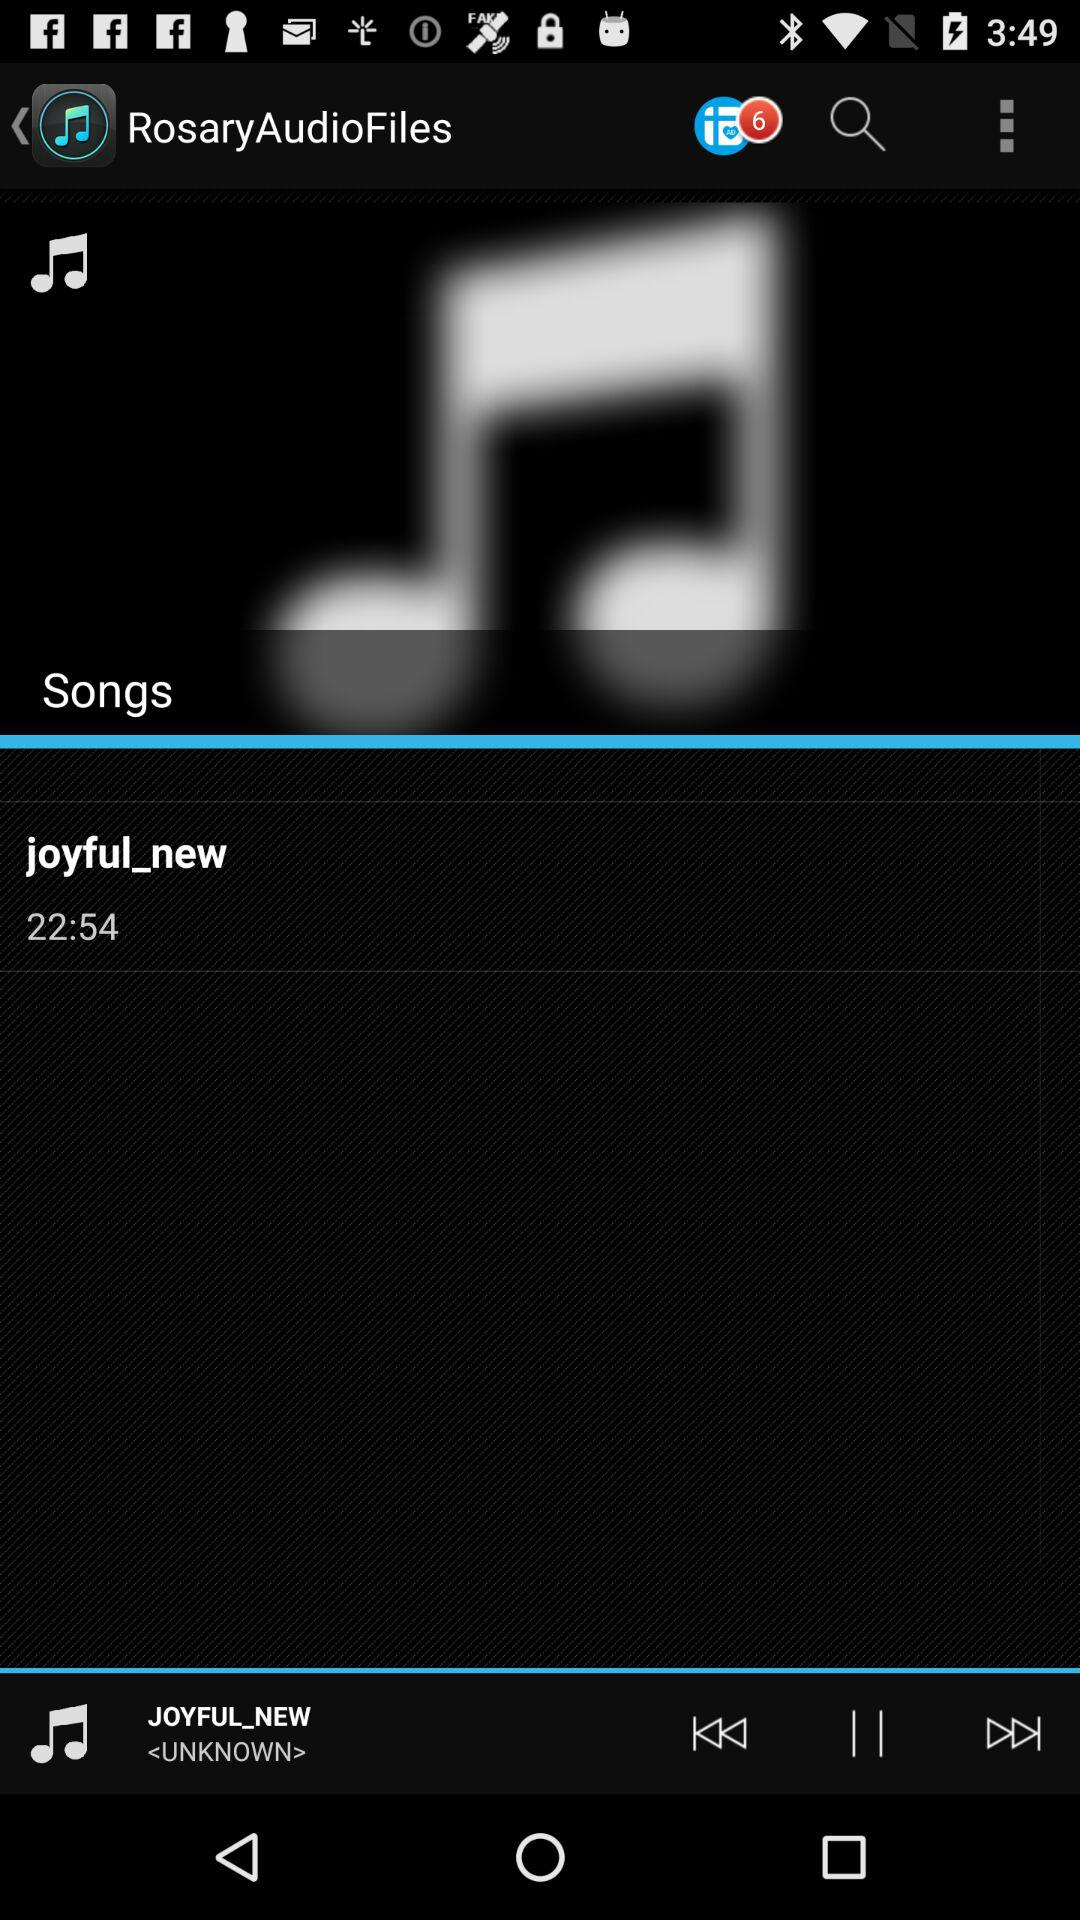What is the name of the song? The name of the song is "joyful_new". 